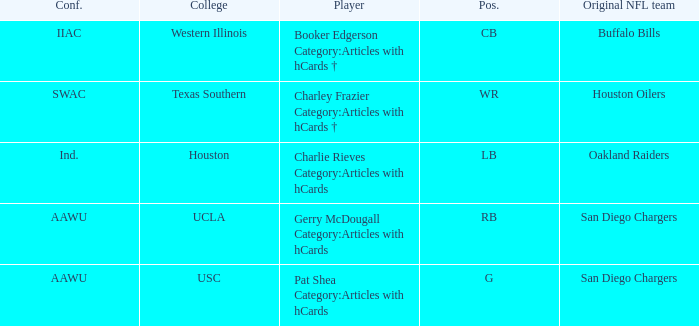What player's original team are the Buffalo Bills? Booker Edgerson Category:Articles with hCards †. 